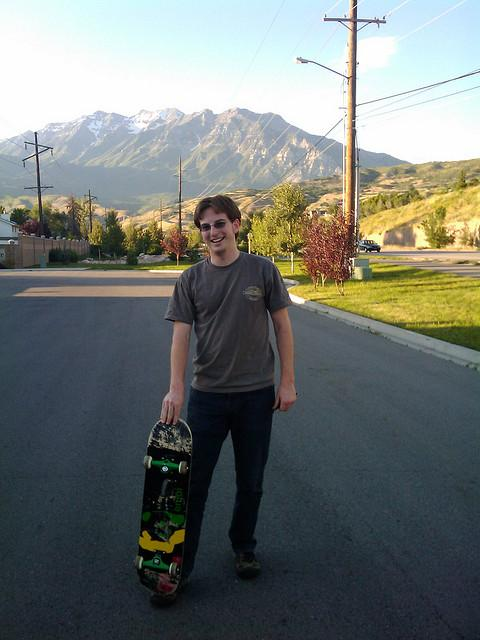What setting does the boarder pose in here? street 